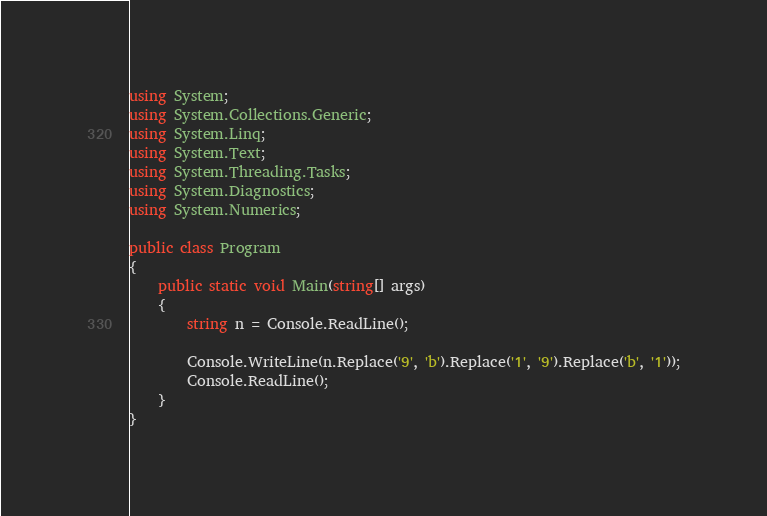<code> <loc_0><loc_0><loc_500><loc_500><_C#_>using System;
using System.Collections.Generic;
using System.Linq;
using System.Text;
using System.Threading.Tasks;
using System.Diagnostics;
using System.Numerics;

public class Program
{
    public static void Main(string[] args)
    {
        string n = Console.ReadLine();

        Console.WriteLine(n.Replace('9', 'b').Replace('1', '9').Replace('b', '1'));
        Console.ReadLine();
    }
}</code> 